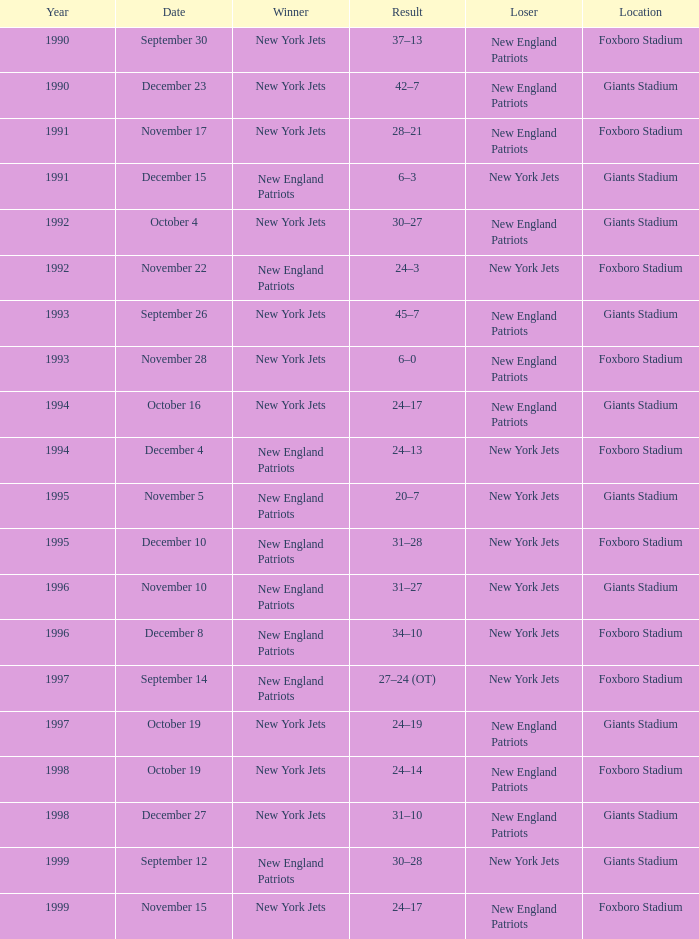What is the year when the Winner was the new york jets, with a Result of 24–17, played at giants stadium? 1994.0. 